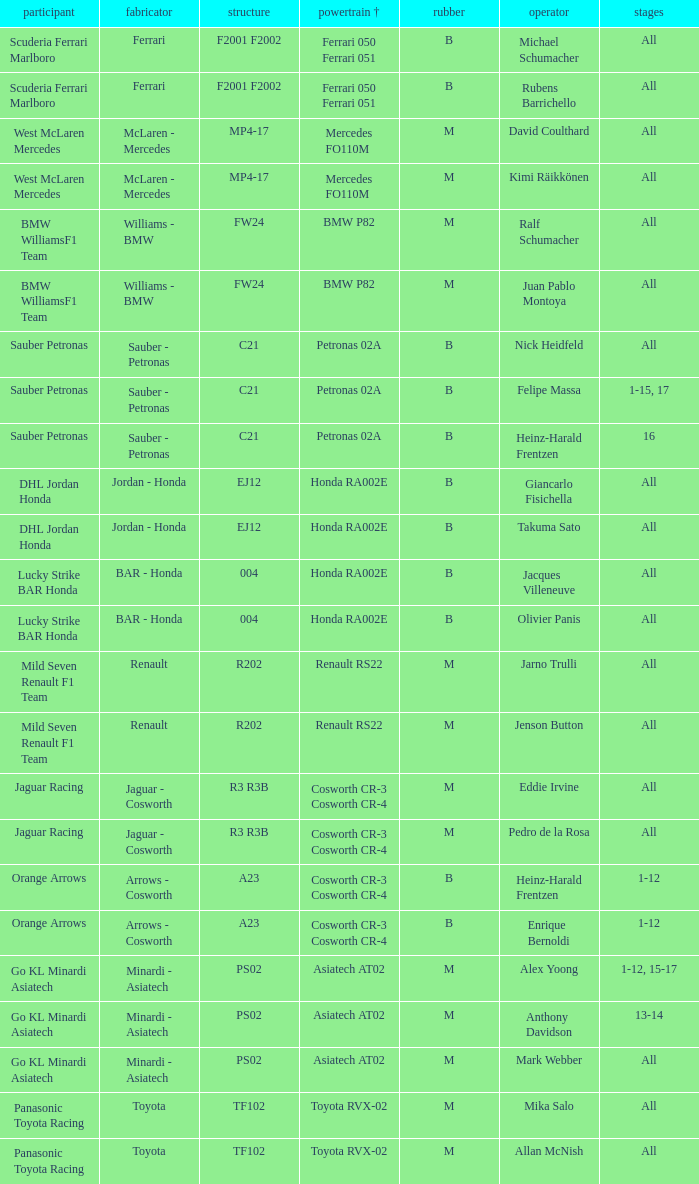Who is the driver when the engine is mercedes fo110m? David Coulthard, Kimi Räikkönen. 